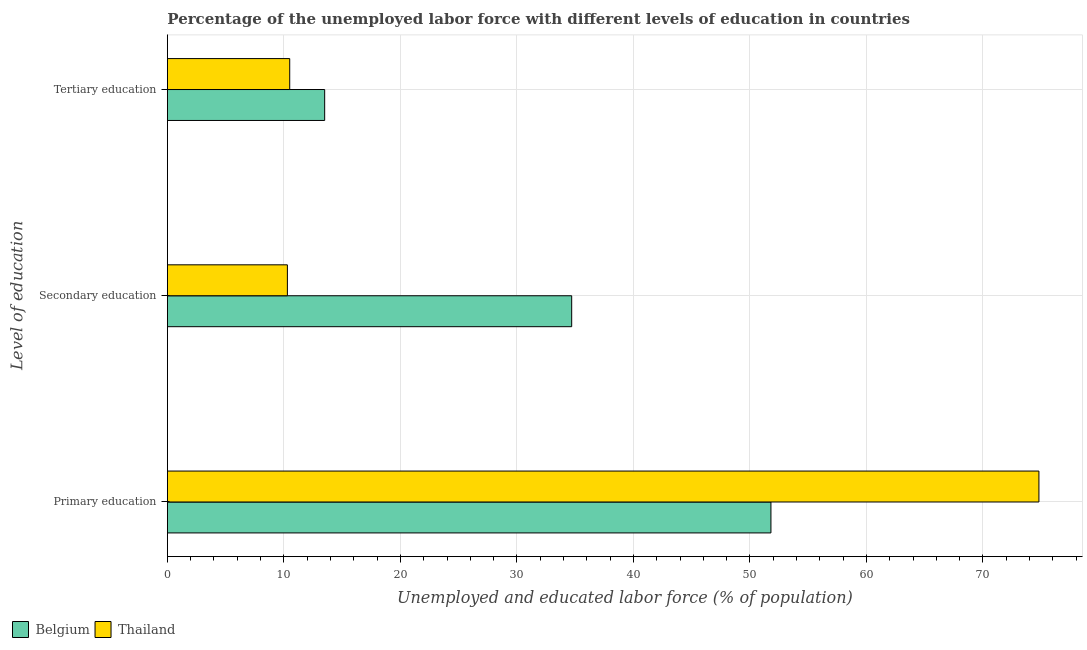How many different coloured bars are there?
Keep it short and to the point. 2. Are the number of bars per tick equal to the number of legend labels?
Make the answer very short. Yes. Are the number of bars on each tick of the Y-axis equal?
Offer a very short reply. Yes. How many bars are there on the 3rd tick from the top?
Offer a terse response. 2. How many bars are there on the 2nd tick from the bottom?
Keep it short and to the point. 2. What is the label of the 1st group of bars from the top?
Your answer should be compact. Tertiary education. What is the percentage of labor force who received secondary education in Thailand?
Provide a short and direct response. 10.3. Across all countries, what is the maximum percentage of labor force who received secondary education?
Your answer should be very brief. 34.7. Across all countries, what is the minimum percentage of labor force who received secondary education?
Ensure brevity in your answer.  10.3. In which country was the percentage of labor force who received primary education maximum?
Provide a succinct answer. Thailand. What is the difference between the percentage of labor force who received tertiary education in Thailand and that in Belgium?
Provide a short and direct response. -3. What is the difference between the percentage of labor force who received secondary education in Thailand and the percentage of labor force who received primary education in Belgium?
Provide a succinct answer. -41.5. What is the average percentage of labor force who received primary education per country?
Ensure brevity in your answer.  63.3. What is the difference between the percentage of labor force who received tertiary education and percentage of labor force who received primary education in Belgium?
Offer a very short reply. -38.3. What is the ratio of the percentage of labor force who received secondary education in Thailand to that in Belgium?
Your answer should be very brief. 0.3. Is the percentage of labor force who received secondary education in Thailand less than that in Belgium?
Give a very brief answer. Yes. What is the difference between the highest and the second highest percentage of labor force who received secondary education?
Make the answer very short. 24.4. What is the difference between the highest and the lowest percentage of labor force who received tertiary education?
Provide a succinct answer. 3. In how many countries, is the percentage of labor force who received primary education greater than the average percentage of labor force who received primary education taken over all countries?
Your answer should be very brief. 1. Is the sum of the percentage of labor force who received primary education in Belgium and Thailand greater than the maximum percentage of labor force who received tertiary education across all countries?
Your answer should be compact. Yes. What does the 2nd bar from the bottom in Secondary education represents?
Provide a short and direct response. Thailand. How many bars are there?
Offer a terse response. 6. How many countries are there in the graph?
Your response must be concise. 2. Are the values on the major ticks of X-axis written in scientific E-notation?
Keep it short and to the point. No. Does the graph contain any zero values?
Provide a succinct answer. No. How many legend labels are there?
Offer a terse response. 2. How are the legend labels stacked?
Offer a terse response. Horizontal. What is the title of the graph?
Provide a succinct answer. Percentage of the unemployed labor force with different levels of education in countries. What is the label or title of the X-axis?
Ensure brevity in your answer.  Unemployed and educated labor force (% of population). What is the label or title of the Y-axis?
Make the answer very short. Level of education. What is the Unemployed and educated labor force (% of population) of Belgium in Primary education?
Provide a succinct answer. 51.8. What is the Unemployed and educated labor force (% of population) in Thailand in Primary education?
Provide a succinct answer. 74.8. What is the Unemployed and educated labor force (% of population) of Belgium in Secondary education?
Your answer should be very brief. 34.7. What is the Unemployed and educated labor force (% of population) of Thailand in Secondary education?
Offer a terse response. 10.3. Across all Level of education, what is the maximum Unemployed and educated labor force (% of population) of Belgium?
Your response must be concise. 51.8. Across all Level of education, what is the maximum Unemployed and educated labor force (% of population) in Thailand?
Provide a short and direct response. 74.8. Across all Level of education, what is the minimum Unemployed and educated labor force (% of population) in Thailand?
Give a very brief answer. 10.3. What is the total Unemployed and educated labor force (% of population) in Thailand in the graph?
Offer a terse response. 95.6. What is the difference between the Unemployed and educated labor force (% of population) of Thailand in Primary education and that in Secondary education?
Make the answer very short. 64.5. What is the difference between the Unemployed and educated labor force (% of population) of Belgium in Primary education and that in Tertiary education?
Your answer should be very brief. 38.3. What is the difference between the Unemployed and educated labor force (% of population) of Thailand in Primary education and that in Tertiary education?
Provide a succinct answer. 64.3. What is the difference between the Unemployed and educated labor force (% of population) of Belgium in Secondary education and that in Tertiary education?
Provide a succinct answer. 21.2. What is the difference between the Unemployed and educated labor force (% of population) of Belgium in Primary education and the Unemployed and educated labor force (% of population) of Thailand in Secondary education?
Your response must be concise. 41.5. What is the difference between the Unemployed and educated labor force (% of population) of Belgium in Primary education and the Unemployed and educated labor force (% of population) of Thailand in Tertiary education?
Give a very brief answer. 41.3. What is the difference between the Unemployed and educated labor force (% of population) of Belgium in Secondary education and the Unemployed and educated labor force (% of population) of Thailand in Tertiary education?
Give a very brief answer. 24.2. What is the average Unemployed and educated labor force (% of population) of Belgium per Level of education?
Make the answer very short. 33.33. What is the average Unemployed and educated labor force (% of population) of Thailand per Level of education?
Ensure brevity in your answer.  31.87. What is the difference between the Unemployed and educated labor force (% of population) in Belgium and Unemployed and educated labor force (% of population) in Thailand in Primary education?
Keep it short and to the point. -23. What is the difference between the Unemployed and educated labor force (% of population) in Belgium and Unemployed and educated labor force (% of population) in Thailand in Secondary education?
Ensure brevity in your answer.  24.4. What is the difference between the Unemployed and educated labor force (% of population) of Belgium and Unemployed and educated labor force (% of population) of Thailand in Tertiary education?
Provide a short and direct response. 3. What is the ratio of the Unemployed and educated labor force (% of population) in Belgium in Primary education to that in Secondary education?
Your answer should be very brief. 1.49. What is the ratio of the Unemployed and educated labor force (% of population) of Thailand in Primary education to that in Secondary education?
Keep it short and to the point. 7.26. What is the ratio of the Unemployed and educated labor force (% of population) in Belgium in Primary education to that in Tertiary education?
Provide a short and direct response. 3.84. What is the ratio of the Unemployed and educated labor force (% of population) of Thailand in Primary education to that in Tertiary education?
Keep it short and to the point. 7.12. What is the ratio of the Unemployed and educated labor force (% of population) in Belgium in Secondary education to that in Tertiary education?
Keep it short and to the point. 2.57. What is the ratio of the Unemployed and educated labor force (% of population) in Thailand in Secondary education to that in Tertiary education?
Offer a terse response. 0.98. What is the difference between the highest and the second highest Unemployed and educated labor force (% of population) in Thailand?
Offer a very short reply. 64.3. What is the difference between the highest and the lowest Unemployed and educated labor force (% of population) of Belgium?
Provide a succinct answer. 38.3. What is the difference between the highest and the lowest Unemployed and educated labor force (% of population) in Thailand?
Your response must be concise. 64.5. 